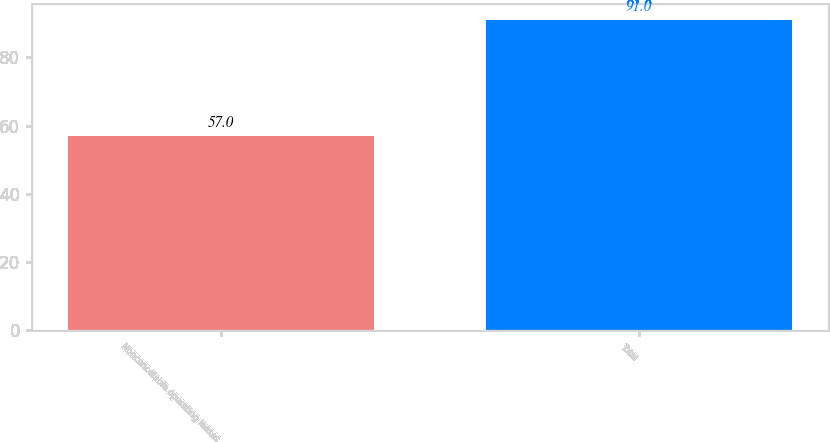Convert chart to OTSL. <chart><loc_0><loc_0><loc_500><loc_500><bar_chart><fcel>Noncancelable operating leases<fcel>Total<nl><fcel>57<fcel>91<nl></chart> 